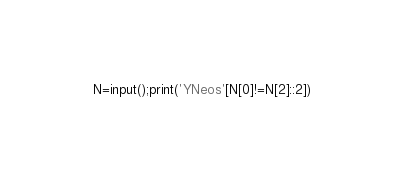<code> <loc_0><loc_0><loc_500><loc_500><_Python_>N=input();print('YNeos'[N[0]!=N[2]::2])</code> 